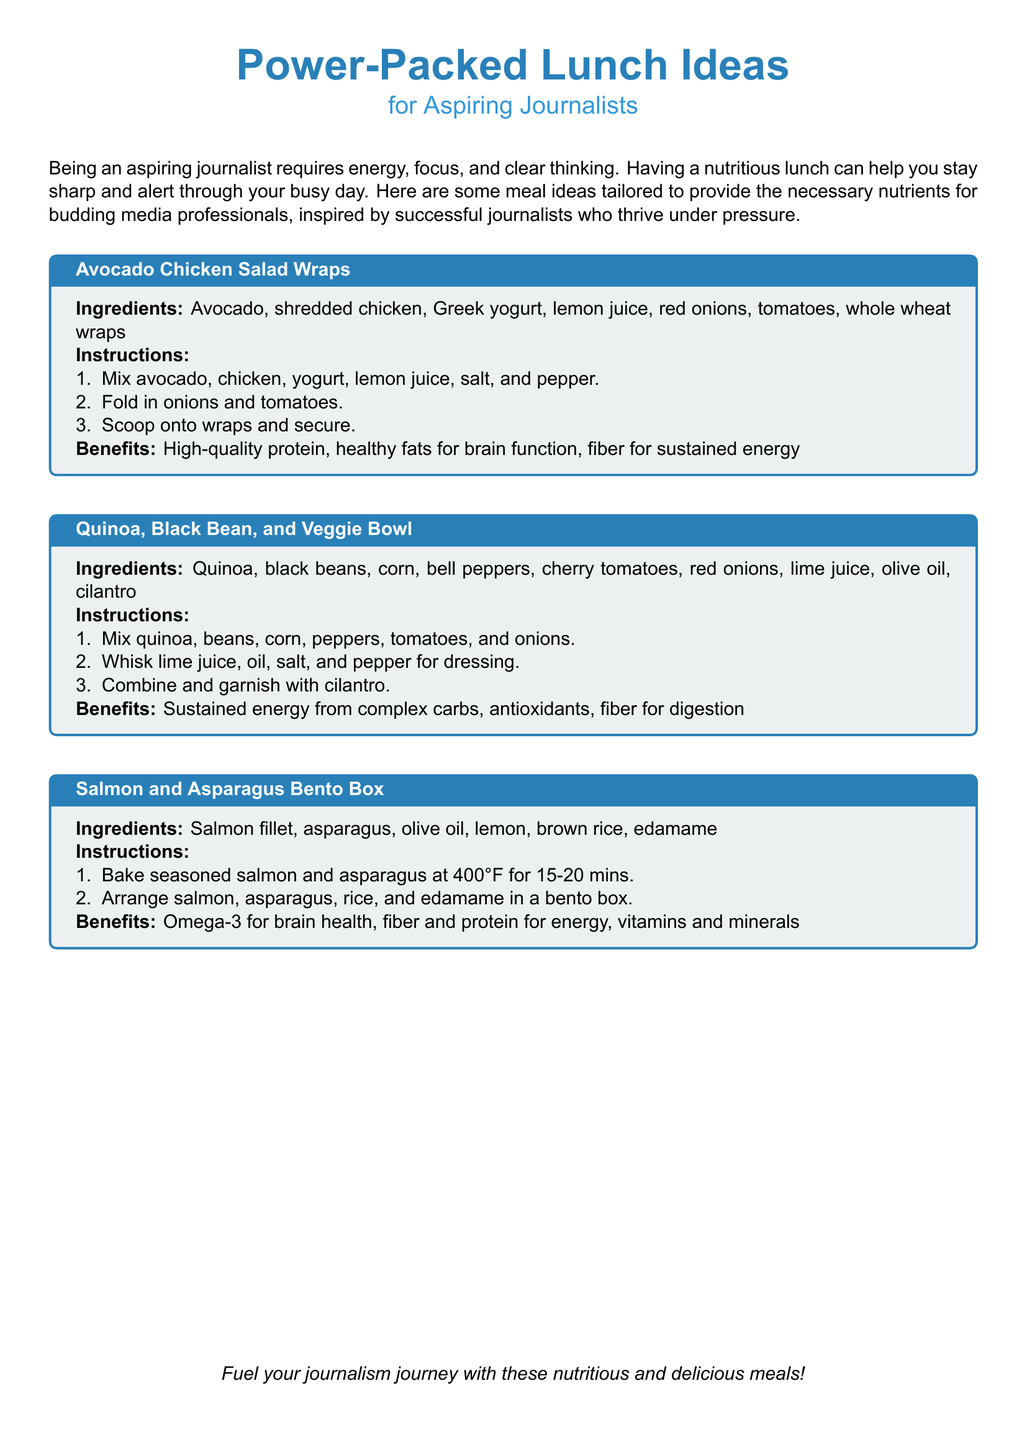What is the first meal idea listed? The first meal idea is found in the document and is titled "Avocado Chicken Salad Wraps".
Answer: Avocado Chicken Salad Wraps What are the main ingredients in the Quinoa, Black Bean, and Veggie Bowl? The document specifies the main ingredients for this meal, which include quinoa, black beans, corn, bell peppers, cherry tomatoes, and red onions.
Answer: Quinoa, black beans, corn, bell peppers, cherry tomatoes, red onions What is one benefit of the Salmon and Asparagus Bento Box? The document provides benefits for this meal, including Omega-3 for brain health.
Answer: Omega-3 for brain health How many minutes should the salmon and asparagus be baked? The document states the baking time for the salmon and asparagus should be 15-20 minutes.
Answer: 15-20 minutes What type of wraps are used in the Avocado Chicken Salad Wraps? The document indicates that whole wheat wraps are used in this meal.
Answer: Whole wheat wraps How many benefits are listed for each meal? The structure of the document details that each meal has one benefit listed.
Answer: One 